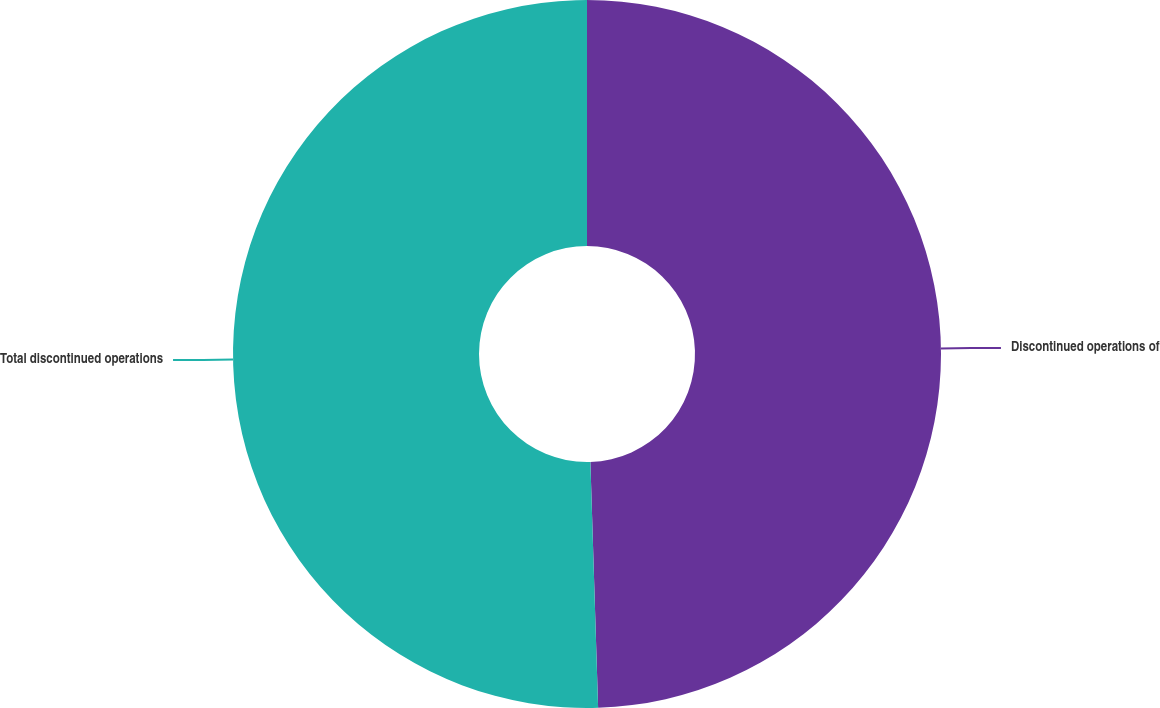Convert chart. <chart><loc_0><loc_0><loc_500><loc_500><pie_chart><fcel>Discontinued operations of<fcel>Total discontinued operations<nl><fcel>49.5%<fcel>50.5%<nl></chart> 